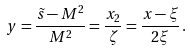<formula> <loc_0><loc_0><loc_500><loc_500>y = \frac { \tilde { s } - M ^ { 2 } } { M ^ { 2 } } = \frac { x _ { 2 } } { \zeta } = \frac { x - \xi } { 2 \xi } \, .</formula> 